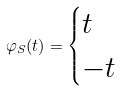<formula> <loc_0><loc_0><loc_500><loc_500>\varphi _ { S } ( t ) = \begin{cases} t & \\ - t & \end{cases}</formula> 